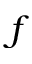<formula> <loc_0><loc_0><loc_500><loc_500>f</formula> 